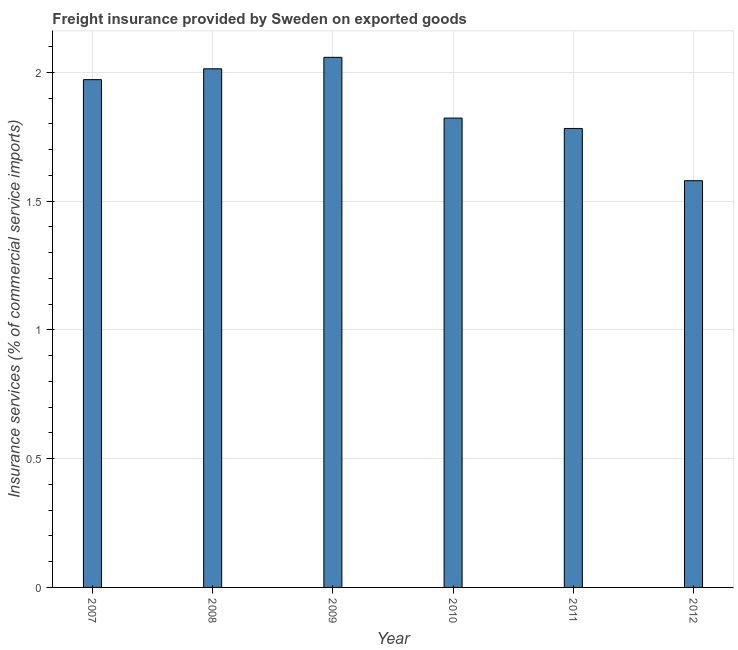Does the graph contain grids?
Give a very brief answer. Yes. What is the title of the graph?
Make the answer very short. Freight insurance provided by Sweden on exported goods . What is the label or title of the Y-axis?
Provide a succinct answer. Insurance services (% of commercial service imports). What is the freight insurance in 2009?
Your response must be concise. 2.06. Across all years, what is the maximum freight insurance?
Make the answer very short. 2.06. Across all years, what is the minimum freight insurance?
Make the answer very short. 1.58. In which year was the freight insurance maximum?
Your response must be concise. 2009. What is the sum of the freight insurance?
Ensure brevity in your answer.  11.23. What is the difference between the freight insurance in 2008 and 2009?
Make the answer very short. -0.04. What is the average freight insurance per year?
Your response must be concise. 1.87. What is the median freight insurance?
Your response must be concise. 1.9. What is the ratio of the freight insurance in 2008 to that in 2010?
Your answer should be very brief. 1.1. Is the freight insurance in 2009 less than that in 2012?
Your response must be concise. No. Is the difference between the freight insurance in 2007 and 2008 greater than the difference between any two years?
Provide a short and direct response. No. What is the difference between the highest and the second highest freight insurance?
Your answer should be compact. 0.04. Is the sum of the freight insurance in 2009 and 2011 greater than the maximum freight insurance across all years?
Make the answer very short. Yes. What is the difference between the highest and the lowest freight insurance?
Offer a very short reply. 0.48. In how many years, is the freight insurance greater than the average freight insurance taken over all years?
Offer a terse response. 3. How many bars are there?
Your answer should be compact. 6. Are all the bars in the graph horizontal?
Your response must be concise. No. How many years are there in the graph?
Offer a very short reply. 6. What is the difference between two consecutive major ticks on the Y-axis?
Provide a succinct answer. 0.5. What is the Insurance services (% of commercial service imports) in 2007?
Your answer should be compact. 1.97. What is the Insurance services (% of commercial service imports) in 2008?
Your response must be concise. 2.01. What is the Insurance services (% of commercial service imports) in 2009?
Offer a very short reply. 2.06. What is the Insurance services (% of commercial service imports) of 2010?
Provide a succinct answer. 1.82. What is the Insurance services (% of commercial service imports) of 2011?
Your response must be concise. 1.78. What is the Insurance services (% of commercial service imports) in 2012?
Make the answer very short. 1.58. What is the difference between the Insurance services (% of commercial service imports) in 2007 and 2008?
Provide a short and direct response. -0.04. What is the difference between the Insurance services (% of commercial service imports) in 2007 and 2009?
Offer a very short reply. -0.09. What is the difference between the Insurance services (% of commercial service imports) in 2007 and 2010?
Offer a very short reply. 0.15. What is the difference between the Insurance services (% of commercial service imports) in 2007 and 2011?
Make the answer very short. 0.19. What is the difference between the Insurance services (% of commercial service imports) in 2007 and 2012?
Your answer should be compact. 0.39. What is the difference between the Insurance services (% of commercial service imports) in 2008 and 2009?
Provide a short and direct response. -0.04. What is the difference between the Insurance services (% of commercial service imports) in 2008 and 2010?
Offer a terse response. 0.19. What is the difference between the Insurance services (% of commercial service imports) in 2008 and 2011?
Provide a succinct answer. 0.23. What is the difference between the Insurance services (% of commercial service imports) in 2008 and 2012?
Keep it short and to the point. 0.43. What is the difference between the Insurance services (% of commercial service imports) in 2009 and 2010?
Your answer should be very brief. 0.24. What is the difference between the Insurance services (% of commercial service imports) in 2009 and 2011?
Provide a short and direct response. 0.28. What is the difference between the Insurance services (% of commercial service imports) in 2009 and 2012?
Give a very brief answer. 0.48. What is the difference between the Insurance services (% of commercial service imports) in 2010 and 2011?
Give a very brief answer. 0.04. What is the difference between the Insurance services (% of commercial service imports) in 2010 and 2012?
Provide a succinct answer. 0.24. What is the difference between the Insurance services (% of commercial service imports) in 2011 and 2012?
Your response must be concise. 0.2. What is the ratio of the Insurance services (% of commercial service imports) in 2007 to that in 2008?
Offer a very short reply. 0.98. What is the ratio of the Insurance services (% of commercial service imports) in 2007 to that in 2009?
Your response must be concise. 0.96. What is the ratio of the Insurance services (% of commercial service imports) in 2007 to that in 2010?
Your answer should be compact. 1.08. What is the ratio of the Insurance services (% of commercial service imports) in 2007 to that in 2011?
Ensure brevity in your answer.  1.11. What is the ratio of the Insurance services (% of commercial service imports) in 2007 to that in 2012?
Provide a succinct answer. 1.25. What is the ratio of the Insurance services (% of commercial service imports) in 2008 to that in 2010?
Your answer should be compact. 1.1. What is the ratio of the Insurance services (% of commercial service imports) in 2008 to that in 2011?
Provide a short and direct response. 1.13. What is the ratio of the Insurance services (% of commercial service imports) in 2008 to that in 2012?
Your response must be concise. 1.27. What is the ratio of the Insurance services (% of commercial service imports) in 2009 to that in 2010?
Ensure brevity in your answer.  1.13. What is the ratio of the Insurance services (% of commercial service imports) in 2009 to that in 2011?
Your answer should be very brief. 1.16. What is the ratio of the Insurance services (% of commercial service imports) in 2009 to that in 2012?
Provide a succinct answer. 1.3. What is the ratio of the Insurance services (% of commercial service imports) in 2010 to that in 2011?
Your response must be concise. 1.02. What is the ratio of the Insurance services (% of commercial service imports) in 2010 to that in 2012?
Offer a terse response. 1.15. What is the ratio of the Insurance services (% of commercial service imports) in 2011 to that in 2012?
Your answer should be very brief. 1.13. 